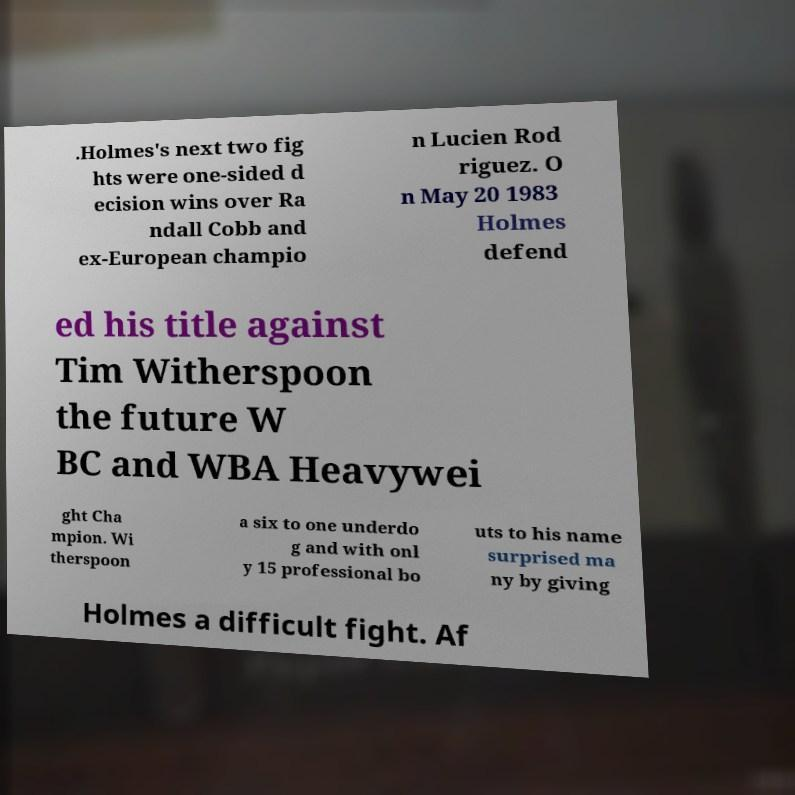I need the written content from this picture converted into text. Can you do that? .Holmes's next two fig hts were one-sided d ecision wins over Ra ndall Cobb and ex-European champio n Lucien Rod riguez. O n May 20 1983 Holmes defend ed his title against Tim Witherspoon the future W BC and WBA Heavywei ght Cha mpion. Wi therspoon a six to one underdo g and with onl y 15 professional bo uts to his name surprised ma ny by giving Holmes a difficult fight. Af 